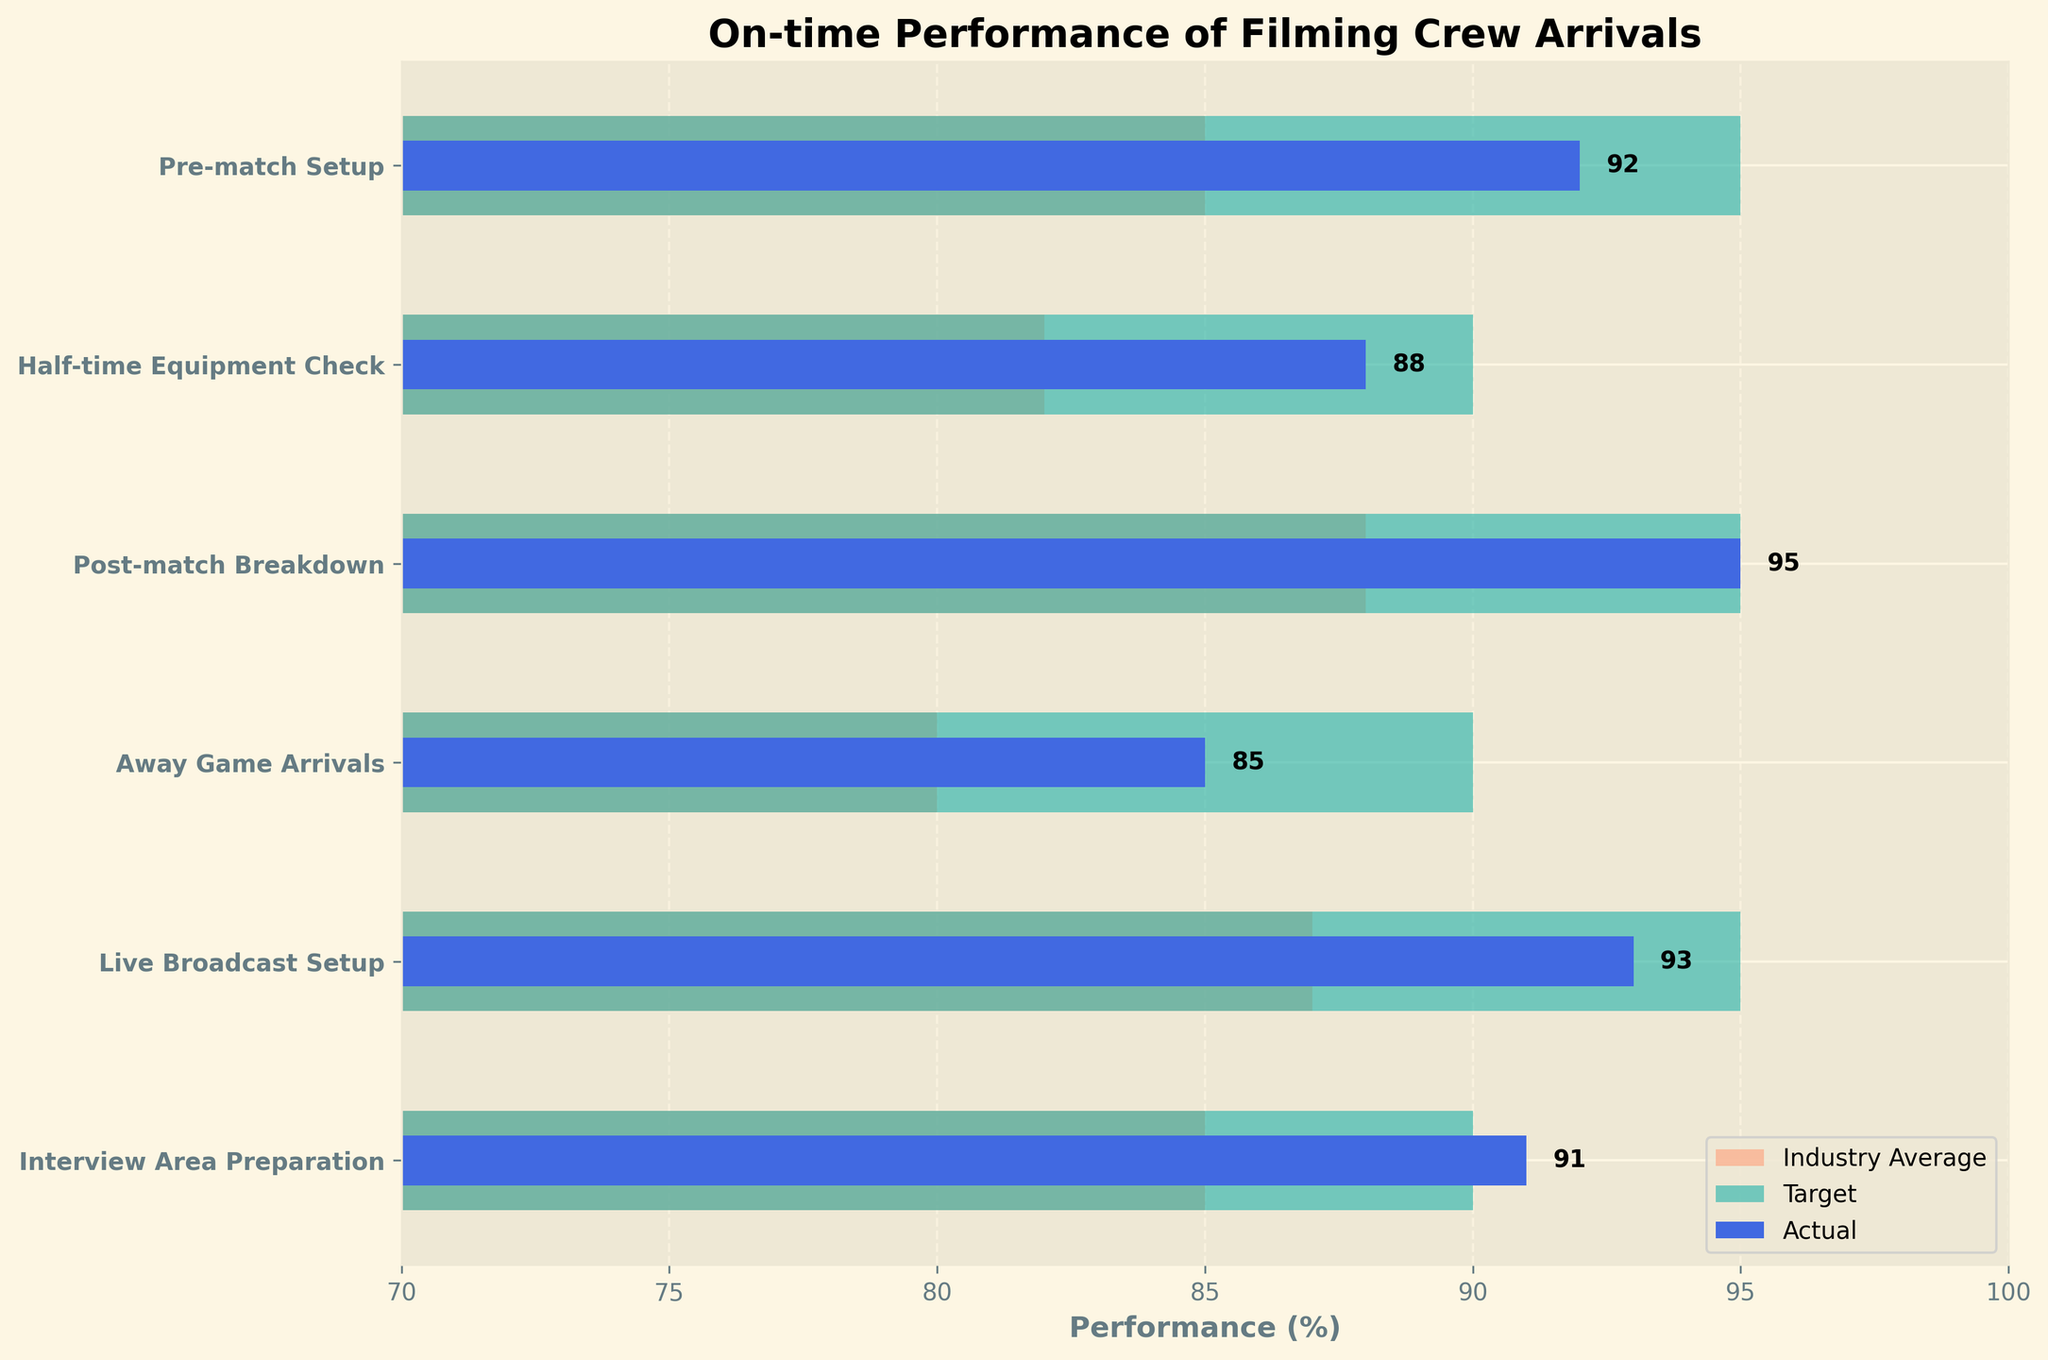What's the title of the figure? The title is usually placed at the top of the figure. It can be read directly from there.
Answer: On-time Performance of Filming Crew Arrivals What is the actual on-time performance for "Post-match Breakdown"? The actual on-time performance for "Post-match Breakdown" is represented by the shorter blue bar next to its label, marked with a number.
Answer: 95% Which category has the lowest actual performance? By examining the lengths of the blue bars, "Away Game Arrivals" has the shortest bar indicating the lowest actual performance.
Answer: Away Game Arrivals How does "Live Broadcast Setup" performance compare to its target? Check the length of the blue bar (Actual) against the green bar (Target) for "Live Broadcast Setup." The actual performance is slightly below the target.
Answer: Slightly below What is the industry average for "Half-time Equipment Check"? This can be found by looking at the length of the orange bar next to "Half-time Equipment Check."
Answer: 82% How many categories have their actual performance meeting or exceeding their targets? Compare each blue bar with its corresponding green bar. Count the categories where the blue bar's length is equal to or more than the green bar. Only "Post-match Breakdown" and "Interview Area Preparation" meet or exceed targets.
Answer: 2 What is the difference between the actual and target performance for "Pre-match Setup"? Subtract the actual performance from the target performance for "Pre-match Setup": 95 - 92.
Answer: 3% Which category's actual performance exceeds the industry average by the largest margin? For each category, find the difference between the actual performance (blue bar) and industry average (orange bar). "Pre-match Setup" has the largest margin, with a difference of 92 - 85.
Answer: Pre-match Setup Which two categories have the closest actual performances? Compare the blue bars’ lengths to find the pair with the smallest difference between their actual performances. "Interview Area Preparation" and "Pre-match Setup" both have close values of 91% and 92%, respectively.
Answer: Interview Area Preparation and Pre-match Setup In which category is the industry average closest to the target performance? Look for the orange and green bars that are nearly equal in a category. Both "Pre-match Setup" and "Interview Area Preparation" have their industry averages close to their targets, but "Interview Area Preparation" shows the smallest gap (90 - 85).
Answer: Interview Area Preparation 